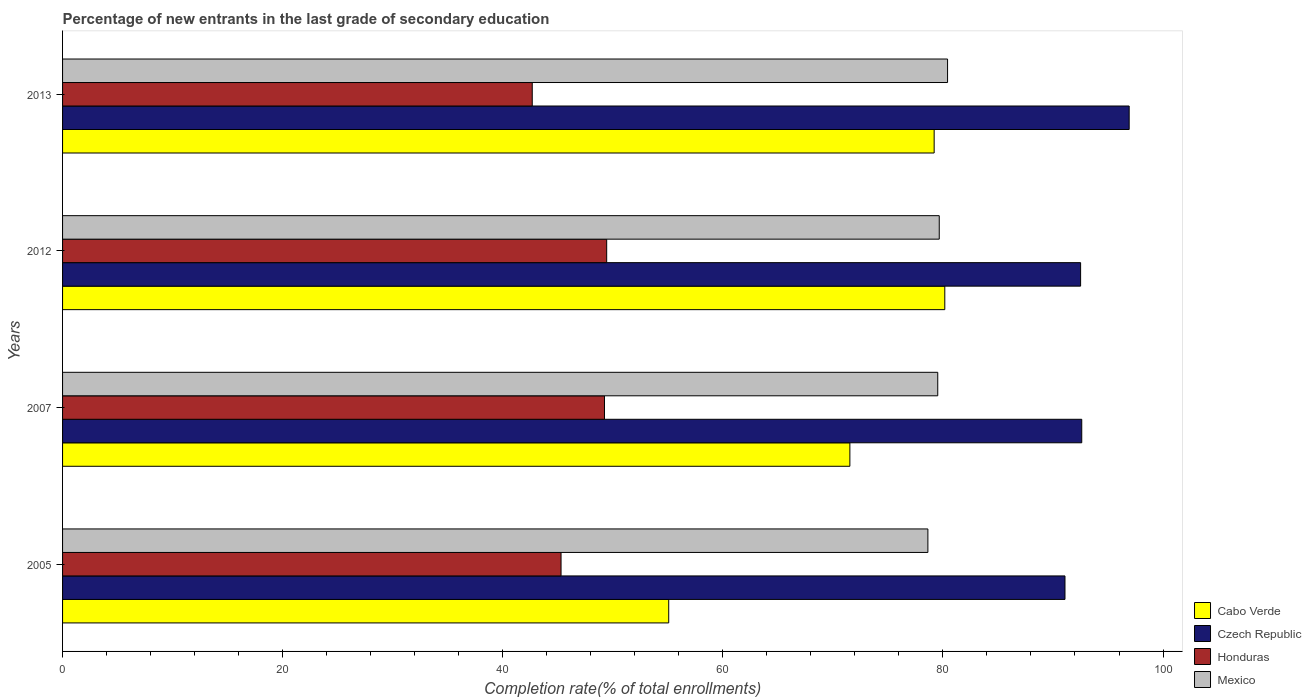Are the number of bars on each tick of the Y-axis equal?
Ensure brevity in your answer.  Yes. How many bars are there on the 3rd tick from the top?
Give a very brief answer. 4. What is the label of the 3rd group of bars from the top?
Your answer should be compact. 2007. What is the percentage of new entrants in Honduras in 2005?
Offer a terse response. 45.3. Across all years, what is the maximum percentage of new entrants in Mexico?
Provide a succinct answer. 80.42. Across all years, what is the minimum percentage of new entrants in Honduras?
Give a very brief answer. 42.68. In which year was the percentage of new entrants in Cabo Verde maximum?
Your answer should be compact. 2012. What is the total percentage of new entrants in Cabo Verde in the graph?
Your answer should be compact. 286. What is the difference between the percentage of new entrants in Mexico in 2005 and that in 2012?
Your response must be concise. -1.03. What is the difference between the percentage of new entrants in Mexico in 2007 and the percentage of new entrants in Honduras in 2013?
Your response must be concise. 36.85. What is the average percentage of new entrants in Mexico per year?
Offer a very short reply. 79.56. In the year 2012, what is the difference between the percentage of new entrants in Mexico and percentage of new entrants in Czech Republic?
Provide a short and direct response. -12.85. In how many years, is the percentage of new entrants in Mexico greater than 72 %?
Your answer should be very brief. 4. What is the ratio of the percentage of new entrants in Mexico in 2007 to that in 2012?
Offer a very short reply. 1. Is the percentage of new entrants in Honduras in 2005 less than that in 2012?
Your answer should be very brief. Yes. Is the difference between the percentage of new entrants in Mexico in 2007 and 2013 greater than the difference between the percentage of new entrants in Czech Republic in 2007 and 2013?
Give a very brief answer. Yes. What is the difference between the highest and the second highest percentage of new entrants in Honduras?
Your response must be concise. 0.2. What is the difference between the highest and the lowest percentage of new entrants in Cabo Verde?
Provide a succinct answer. 25.09. Is the sum of the percentage of new entrants in Cabo Verde in 2012 and 2013 greater than the maximum percentage of new entrants in Czech Republic across all years?
Offer a very short reply. Yes. What does the 2nd bar from the top in 2005 represents?
Provide a succinct answer. Honduras. What does the 2nd bar from the bottom in 2007 represents?
Offer a very short reply. Czech Republic. Is it the case that in every year, the sum of the percentage of new entrants in Czech Republic and percentage of new entrants in Honduras is greater than the percentage of new entrants in Cabo Verde?
Make the answer very short. Yes. How many bars are there?
Offer a very short reply. 16. Are all the bars in the graph horizontal?
Give a very brief answer. Yes. How many years are there in the graph?
Give a very brief answer. 4. Does the graph contain any zero values?
Give a very brief answer. No. How many legend labels are there?
Make the answer very short. 4. What is the title of the graph?
Your response must be concise. Percentage of new entrants in the last grade of secondary education. Does "Sierra Leone" appear as one of the legend labels in the graph?
Ensure brevity in your answer.  No. What is the label or title of the X-axis?
Provide a short and direct response. Completion rate(% of total enrollments). What is the Completion rate(% of total enrollments) in Cabo Verde in 2005?
Your answer should be compact. 55.08. What is the Completion rate(% of total enrollments) of Czech Republic in 2005?
Make the answer very short. 91.09. What is the Completion rate(% of total enrollments) in Honduras in 2005?
Your answer should be very brief. 45.3. What is the Completion rate(% of total enrollments) in Mexico in 2005?
Your response must be concise. 78.63. What is the Completion rate(% of total enrollments) in Cabo Verde in 2007?
Your answer should be very brief. 71.54. What is the Completion rate(% of total enrollments) of Czech Republic in 2007?
Ensure brevity in your answer.  92.61. What is the Completion rate(% of total enrollments) of Honduras in 2007?
Ensure brevity in your answer.  49.24. What is the Completion rate(% of total enrollments) of Mexico in 2007?
Your response must be concise. 79.53. What is the Completion rate(% of total enrollments) of Cabo Verde in 2012?
Provide a short and direct response. 80.17. What is the Completion rate(% of total enrollments) of Czech Republic in 2012?
Your answer should be compact. 92.51. What is the Completion rate(% of total enrollments) in Honduras in 2012?
Offer a very short reply. 49.45. What is the Completion rate(% of total enrollments) of Mexico in 2012?
Offer a very short reply. 79.67. What is the Completion rate(% of total enrollments) of Cabo Verde in 2013?
Provide a short and direct response. 79.2. What is the Completion rate(% of total enrollments) in Czech Republic in 2013?
Give a very brief answer. 96.92. What is the Completion rate(% of total enrollments) of Honduras in 2013?
Provide a short and direct response. 42.68. What is the Completion rate(% of total enrollments) of Mexico in 2013?
Offer a terse response. 80.42. Across all years, what is the maximum Completion rate(% of total enrollments) in Cabo Verde?
Your answer should be very brief. 80.17. Across all years, what is the maximum Completion rate(% of total enrollments) in Czech Republic?
Give a very brief answer. 96.92. Across all years, what is the maximum Completion rate(% of total enrollments) in Honduras?
Provide a short and direct response. 49.45. Across all years, what is the maximum Completion rate(% of total enrollments) of Mexico?
Provide a succinct answer. 80.42. Across all years, what is the minimum Completion rate(% of total enrollments) in Cabo Verde?
Give a very brief answer. 55.08. Across all years, what is the minimum Completion rate(% of total enrollments) in Czech Republic?
Your response must be concise. 91.09. Across all years, what is the minimum Completion rate(% of total enrollments) of Honduras?
Give a very brief answer. 42.68. Across all years, what is the minimum Completion rate(% of total enrollments) in Mexico?
Offer a terse response. 78.63. What is the total Completion rate(% of total enrollments) in Cabo Verde in the graph?
Offer a very short reply. 286. What is the total Completion rate(% of total enrollments) of Czech Republic in the graph?
Ensure brevity in your answer.  373.14. What is the total Completion rate(% of total enrollments) in Honduras in the graph?
Give a very brief answer. 186.67. What is the total Completion rate(% of total enrollments) of Mexico in the graph?
Your response must be concise. 318.25. What is the difference between the Completion rate(% of total enrollments) of Cabo Verde in 2005 and that in 2007?
Your answer should be very brief. -16.46. What is the difference between the Completion rate(% of total enrollments) of Czech Republic in 2005 and that in 2007?
Provide a succinct answer. -1.52. What is the difference between the Completion rate(% of total enrollments) in Honduras in 2005 and that in 2007?
Provide a succinct answer. -3.95. What is the difference between the Completion rate(% of total enrollments) of Mexico in 2005 and that in 2007?
Make the answer very short. -0.9. What is the difference between the Completion rate(% of total enrollments) in Cabo Verde in 2005 and that in 2012?
Your answer should be compact. -25.09. What is the difference between the Completion rate(% of total enrollments) of Czech Republic in 2005 and that in 2012?
Give a very brief answer. -1.42. What is the difference between the Completion rate(% of total enrollments) of Honduras in 2005 and that in 2012?
Provide a succinct answer. -4.15. What is the difference between the Completion rate(% of total enrollments) in Mexico in 2005 and that in 2012?
Offer a very short reply. -1.03. What is the difference between the Completion rate(% of total enrollments) of Cabo Verde in 2005 and that in 2013?
Offer a terse response. -24.12. What is the difference between the Completion rate(% of total enrollments) in Czech Republic in 2005 and that in 2013?
Your answer should be compact. -5.83. What is the difference between the Completion rate(% of total enrollments) of Honduras in 2005 and that in 2013?
Your answer should be very brief. 2.62. What is the difference between the Completion rate(% of total enrollments) of Mexico in 2005 and that in 2013?
Give a very brief answer. -1.79. What is the difference between the Completion rate(% of total enrollments) in Cabo Verde in 2007 and that in 2012?
Offer a terse response. -8.63. What is the difference between the Completion rate(% of total enrollments) in Czech Republic in 2007 and that in 2012?
Give a very brief answer. 0.1. What is the difference between the Completion rate(% of total enrollments) in Honduras in 2007 and that in 2012?
Keep it short and to the point. -0.2. What is the difference between the Completion rate(% of total enrollments) of Mexico in 2007 and that in 2012?
Your response must be concise. -0.14. What is the difference between the Completion rate(% of total enrollments) of Cabo Verde in 2007 and that in 2013?
Your answer should be compact. -7.66. What is the difference between the Completion rate(% of total enrollments) in Czech Republic in 2007 and that in 2013?
Provide a short and direct response. -4.31. What is the difference between the Completion rate(% of total enrollments) of Honduras in 2007 and that in 2013?
Your response must be concise. 6.56. What is the difference between the Completion rate(% of total enrollments) of Mexico in 2007 and that in 2013?
Offer a very short reply. -0.89. What is the difference between the Completion rate(% of total enrollments) in Cabo Verde in 2012 and that in 2013?
Provide a short and direct response. 0.97. What is the difference between the Completion rate(% of total enrollments) in Czech Republic in 2012 and that in 2013?
Offer a very short reply. -4.41. What is the difference between the Completion rate(% of total enrollments) in Honduras in 2012 and that in 2013?
Your answer should be very brief. 6.77. What is the difference between the Completion rate(% of total enrollments) in Mexico in 2012 and that in 2013?
Ensure brevity in your answer.  -0.75. What is the difference between the Completion rate(% of total enrollments) in Cabo Verde in 2005 and the Completion rate(% of total enrollments) in Czech Republic in 2007?
Your response must be concise. -37.53. What is the difference between the Completion rate(% of total enrollments) in Cabo Verde in 2005 and the Completion rate(% of total enrollments) in Honduras in 2007?
Keep it short and to the point. 5.84. What is the difference between the Completion rate(% of total enrollments) of Cabo Verde in 2005 and the Completion rate(% of total enrollments) of Mexico in 2007?
Your answer should be compact. -24.45. What is the difference between the Completion rate(% of total enrollments) in Czech Republic in 2005 and the Completion rate(% of total enrollments) in Honduras in 2007?
Offer a terse response. 41.85. What is the difference between the Completion rate(% of total enrollments) of Czech Republic in 2005 and the Completion rate(% of total enrollments) of Mexico in 2007?
Your answer should be compact. 11.56. What is the difference between the Completion rate(% of total enrollments) of Honduras in 2005 and the Completion rate(% of total enrollments) of Mexico in 2007?
Your answer should be very brief. -34.23. What is the difference between the Completion rate(% of total enrollments) of Cabo Verde in 2005 and the Completion rate(% of total enrollments) of Czech Republic in 2012?
Your response must be concise. -37.43. What is the difference between the Completion rate(% of total enrollments) of Cabo Verde in 2005 and the Completion rate(% of total enrollments) of Honduras in 2012?
Offer a very short reply. 5.64. What is the difference between the Completion rate(% of total enrollments) in Cabo Verde in 2005 and the Completion rate(% of total enrollments) in Mexico in 2012?
Provide a succinct answer. -24.58. What is the difference between the Completion rate(% of total enrollments) of Czech Republic in 2005 and the Completion rate(% of total enrollments) of Honduras in 2012?
Give a very brief answer. 41.65. What is the difference between the Completion rate(% of total enrollments) in Czech Republic in 2005 and the Completion rate(% of total enrollments) in Mexico in 2012?
Provide a succinct answer. 11.43. What is the difference between the Completion rate(% of total enrollments) in Honduras in 2005 and the Completion rate(% of total enrollments) in Mexico in 2012?
Your answer should be very brief. -34.37. What is the difference between the Completion rate(% of total enrollments) in Cabo Verde in 2005 and the Completion rate(% of total enrollments) in Czech Republic in 2013?
Offer a terse response. -41.84. What is the difference between the Completion rate(% of total enrollments) of Cabo Verde in 2005 and the Completion rate(% of total enrollments) of Honduras in 2013?
Your answer should be very brief. 12.4. What is the difference between the Completion rate(% of total enrollments) of Cabo Verde in 2005 and the Completion rate(% of total enrollments) of Mexico in 2013?
Make the answer very short. -25.34. What is the difference between the Completion rate(% of total enrollments) in Czech Republic in 2005 and the Completion rate(% of total enrollments) in Honduras in 2013?
Ensure brevity in your answer.  48.41. What is the difference between the Completion rate(% of total enrollments) in Czech Republic in 2005 and the Completion rate(% of total enrollments) in Mexico in 2013?
Provide a succinct answer. 10.67. What is the difference between the Completion rate(% of total enrollments) of Honduras in 2005 and the Completion rate(% of total enrollments) of Mexico in 2013?
Give a very brief answer. -35.12. What is the difference between the Completion rate(% of total enrollments) of Cabo Verde in 2007 and the Completion rate(% of total enrollments) of Czech Republic in 2012?
Offer a terse response. -20.97. What is the difference between the Completion rate(% of total enrollments) in Cabo Verde in 2007 and the Completion rate(% of total enrollments) in Honduras in 2012?
Keep it short and to the point. 22.1. What is the difference between the Completion rate(% of total enrollments) of Cabo Verde in 2007 and the Completion rate(% of total enrollments) of Mexico in 2012?
Offer a very short reply. -8.12. What is the difference between the Completion rate(% of total enrollments) in Czech Republic in 2007 and the Completion rate(% of total enrollments) in Honduras in 2012?
Ensure brevity in your answer.  43.17. What is the difference between the Completion rate(% of total enrollments) in Czech Republic in 2007 and the Completion rate(% of total enrollments) in Mexico in 2012?
Your response must be concise. 12.95. What is the difference between the Completion rate(% of total enrollments) in Honduras in 2007 and the Completion rate(% of total enrollments) in Mexico in 2012?
Your answer should be very brief. -30.42. What is the difference between the Completion rate(% of total enrollments) of Cabo Verde in 2007 and the Completion rate(% of total enrollments) of Czech Republic in 2013?
Make the answer very short. -25.38. What is the difference between the Completion rate(% of total enrollments) of Cabo Verde in 2007 and the Completion rate(% of total enrollments) of Honduras in 2013?
Keep it short and to the point. 28.86. What is the difference between the Completion rate(% of total enrollments) of Cabo Verde in 2007 and the Completion rate(% of total enrollments) of Mexico in 2013?
Offer a very short reply. -8.88. What is the difference between the Completion rate(% of total enrollments) in Czech Republic in 2007 and the Completion rate(% of total enrollments) in Honduras in 2013?
Provide a short and direct response. 49.93. What is the difference between the Completion rate(% of total enrollments) of Czech Republic in 2007 and the Completion rate(% of total enrollments) of Mexico in 2013?
Offer a terse response. 12.2. What is the difference between the Completion rate(% of total enrollments) of Honduras in 2007 and the Completion rate(% of total enrollments) of Mexico in 2013?
Keep it short and to the point. -31.18. What is the difference between the Completion rate(% of total enrollments) in Cabo Verde in 2012 and the Completion rate(% of total enrollments) in Czech Republic in 2013?
Your answer should be very brief. -16.75. What is the difference between the Completion rate(% of total enrollments) of Cabo Verde in 2012 and the Completion rate(% of total enrollments) of Honduras in 2013?
Your answer should be very brief. 37.49. What is the difference between the Completion rate(% of total enrollments) of Cabo Verde in 2012 and the Completion rate(% of total enrollments) of Mexico in 2013?
Ensure brevity in your answer.  -0.25. What is the difference between the Completion rate(% of total enrollments) of Czech Republic in 2012 and the Completion rate(% of total enrollments) of Honduras in 2013?
Keep it short and to the point. 49.83. What is the difference between the Completion rate(% of total enrollments) of Czech Republic in 2012 and the Completion rate(% of total enrollments) of Mexico in 2013?
Your response must be concise. 12.09. What is the difference between the Completion rate(% of total enrollments) of Honduras in 2012 and the Completion rate(% of total enrollments) of Mexico in 2013?
Offer a very short reply. -30.97. What is the average Completion rate(% of total enrollments) in Cabo Verde per year?
Keep it short and to the point. 71.5. What is the average Completion rate(% of total enrollments) in Czech Republic per year?
Your response must be concise. 93.28. What is the average Completion rate(% of total enrollments) of Honduras per year?
Your answer should be compact. 46.67. What is the average Completion rate(% of total enrollments) of Mexico per year?
Your response must be concise. 79.56. In the year 2005, what is the difference between the Completion rate(% of total enrollments) in Cabo Verde and Completion rate(% of total enrollments) in Czech Republic?
Offer a terse response. -36.01. In the year 2005, what is the difference between the Completion rate(% of total enrollments) in Cabo Verde and Completion rate(% of total enrollments) in Honduras?
Keep it short and to the point. 9.78. In the year 2005, what is the difference between the Completion rate(% of total enrollments) in Cabo Verde and Completion rate(% of total enrollments) in Mexico?
Keep it short and to the point. -23.55. In the year 2005, what is the difference between the Completion rate(% of total enrollments) of Czech Republic and Completion rate(% of total enrollments) of Honduras?
Keep it short and to the point. 45.79. In the year 2005, what is the difference between the Completion rate(% of total enrollments) of Czech Republic and Completion rate(% of total enrollments) of Mexico?
Offer a terse response. 12.46. In the year 2005, what is the difference between the Completion rate(% of total enrollments) in Honduras and Completion rate(% of total enrollments) in Mexico?
Your response must be concise. -33.34. In the year 2007, what is the difference between the Completion rate(% of total enrollments) of Cabo Verde and Completion rate(% of total enrollments) of Czech Republic?
Your answer should be very brief. -21.07. In the year 2007, what is the difference between the Completion rate(% of total enrollments) of Cabo Verde and Completion rate(% of total enrollments) of Honduras?
Make the answer very short. 22.3. In the year 2007, what is the difference between the Completion rate(% of total enrollments) of Cabo Verde and Completion rate(% of total enrollments) of Mexico?
Your answer should be compact. -7.99. In the year 2007, what is the difference between the Completion rate(% of total enrollments) in Czech Republic and Completion rate(% of total enrollments) in Honduras?
Provide a short and direct response. 43.37. In the year 2007, what is the difference between the Completion rate(% of total enrollments) in Czech Republic and Completion rate(% of total enrollments) in Mexico?
Provide a short and direct response. 13.09. In the year 2007, what is the difference between the Completion rate(% of total enrollments) of Honduras and Completion rate(% of total enrollments) of Mexico?
Your answer should be very brief. -30.29. In the year 2012, what is the difference between the Completion rate(% of total enrollments) in Cabo Verde and Completion rate(% of total enrollments) in Czech Republic?
Ensure brevity in your answer.  -12.34. In the year 2012, what is the difference between the Completion rate(% of total enrollments) in Cabo Verde and Completion rate(% of total enrollments) in Honduras?
Give a very brief answer. 30.72. In the year 2012, what is the difference between the Completion rate(% of total enrollments) of Cabo Verde and Completion rate(% of total enrollments) of Mexico?
Make the answer very short. 0.5. In the year 2012, what is the difference between the Completion rate(% of total enrollments) of Czech Republic and Completion rate(% of total enrollments) of Honduras?
Provide a succinct answer. 43.07. In the year 2012, what is the difference between the Completion rate(% of total enrollments) in Czech Republic and Completion rate(% of total enrollments) in Mexico?
Make the answer very short. 12.85. In the year 2012, what is the difference between the Completion rate(% of total enrollments) of Honduras and Completion rate(% of total enrollments) of Mexico?
Provide a short and direct response. -30.22. In the year 2013, what is the difference between the Completion rate(% of total enrollments) in Cabo Verde and Completion rate(% of total enrollments) in Czech Republic?
Provide a succinct answer. -17.72. In the year 2013, what is the difference between the Completion rate(% of total enrollments) in Cabo Verde and Completion rate(% of total enrollments) in Honduras?
Keep it short and to the point. 36.52. In the year 2013, what is the difference between the Completion rate(% of total enrollments) of Cabo Verde and Completion rate(% of total enrollments) of Mexico?
Your answer should be compact. -1.22. In the year 2013, what is the difference between the Completion rate(% of total enrollments) of Czech Republic and Completion rate(% of total enrollments) of Honduras?
Offer a very short reply. 54.24. In the year 2013, what is the difference between the Completion rate(% of total enrollments) in Czech Republic and Completion rate(% of total enrollments) in Mexico?
Your answer should be compact. 16.5. In the year 2013, what is the difference between the Completion rate(% of total enrollments) in Honduras and Completion rate(% of total enrollments) in Mexico?
Provide a short and direct response. -37.74. What is the ratio of the Completion rate(% of total enrollments) in Cabo Verde in 2005 to that in 2007?
Offer a terse response. 0.77. What is the ratio of the Completion rate(% of total enrollments) in Czech Republic in 2005 to that in 2007?
Provide a short and direct response. 0.98. What is the ratio of the Completion rate(% of total enrollments) in Honduras in 2005 to that in 2007?
Ensure brevity in your answer.  0.92. What is the ratio of the Completion rate(% of total enrollments) in Mexico in 2005 to that in 2007?
Give a very brief answer. 0.99. What is the ratio of the Completion rate(% of total enrollments) in Cabo Verde in 2005 to that in 2012?
Make the answer very short. 0.69. What is the ratio of the Completion rate(% of total enrollments) of Czech Republic in 2005 to that in 2012?
Your answer should be compact. 0.98. What is the ratio of the Completion rate(% of total enrollments) of Honduras in 2005 to that in 2012?
Provide a short and direct response. 0.92. What is the ratio of the Completion rate(% of total enrollments) in Cabo Verde in 2005 to that in 2013?
Ensure brevity in your answer.  0.7. What is the ratio of the Completion rate(% of total enrollments) in Czech Republic in 2005 to that in 2013?
Your answer should be compact. 0.94. What is the ratio of the Completion rate(% of total enrollments) of Honduras in 2005 to that in 2013?
Provide a short and direct response. 1.06. What is the ratio of the Completion rate(% of total enrollments) of Mexico in 2005 to that in 2013?
Ensure brevity in your answer.  0.98. What is the ratio of the Completion rate(% of total enrollments) in Cabo Verde in 2007 to that in 2012?
Make the answer very short. 0.89. What is the ratio of the Completion rate(% of total enrollments) of Czech Republic in 2007 to that in 2012?
Your answer should be very brief. 1. What is the ratio of the Completion rate(% of total enrollments) of Mexico in 2007 to that in 2012?
Your answer should be compact. 1. What is the ratio of the Completion rate(% of total enrollments) of Cabo Verde in 2007 to that in 2013?
Provide a succinct answer. 0.9. What is the ratio of the Completion rate(% of total enrollments) of Czech Republic in 2007 to that in 2013?
Keep it short and to the point. 0.96. What is the ratio of the Completion rate(% of total enrollments) of Honduras in 2007 to that in 2013?
Give a very brief answer. 1.15. What is the ratio of the Completion rate(% of total enrollments) in Mexico in 2007 to that in 2013?
Offer a terse response. 0.99. What is the ratio of the Completion rate(% of total enrollments) in Cabo Verde in 2012 to that in 2013?
Provide a short and direct response. 1.01. What is the ratio of the Completion rate(% of total enrollments) of Czech Republic in 2012 to that in 2013?
Offer a terse response. 0.95. What is the ratio of the Completion rate(% of total enrollments) in Honduras in 2012 to that in 2013?
Ensure brevity in your answer.  1.16. What is the ratio of the Completion rate(% of total enrollments) of Mexico in 2012 to that in 2013?
Provide a short and direct response. 0.99. What is the difference between the highest and the second highest Completion rate(% of total enrollments) of Cabo Verde?
Give a very brief answer. 0.97. What is the difference between the highest and the second highest Completion rate(% of total enrollments) in Czech Republic?
Provide a short and direct response. 4.31. What is the difference between the highest and the second highest Completion rate(% of total enrollments) of Honduras?
Offer a very short reply. 0.2. What is the difference between the highest and the second highest Completion rate(% of total enrollments) of Mexico?
Offer a terse response. 0.75. What is the difference between the highest and the lowest Completion rate(% of total enrollments) in Cabo Verde?
Your answer should be compact. 25.09. What is the difference between the highest and the lowest Completion rate(% of total enrollments) of Czech Republic?
Give a very brief answer. 5.83. What is the difference between the highest and the lowest Completion rate(% of total enrollments) of Honduras?
Your answer should be very brief. 6.77. What is the difference between the highest and the lowest Completion rate(% of total enrollments) of Mexico?
Provide a short and direct response. 1.79. 